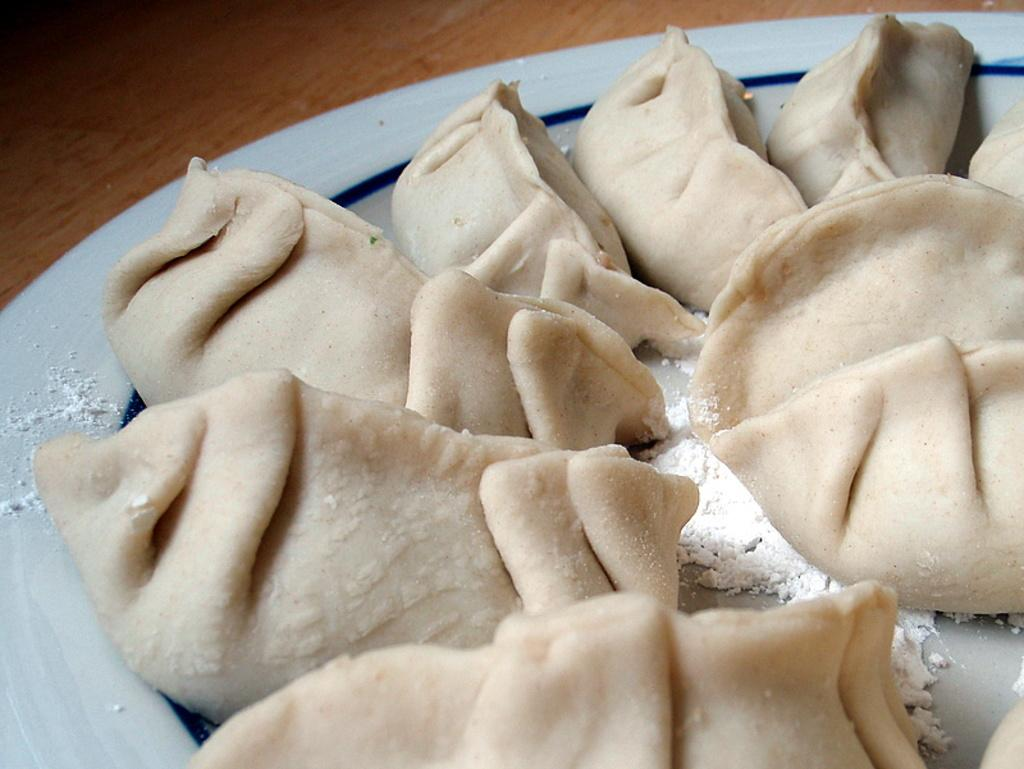What is on the plate that is visible in the image? There is food on a plate in the image. Where is the plate located in the image? The plate is placed on a wooden table. What type of thread is being used by the kitten to express its desire in the image? There is no kitten or thread present in the image. 